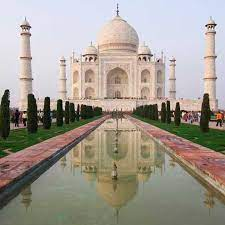How does the architecture of the Taj Mahal incorporate elements of Islamic art? The architecture of the Taj Mahal is a brilliant amalgamation of Islamic art principles, including the use of Islamic arches, intricate arabesque designs, and geometric patterns. The main dome, topped with a lotus design, is an excellent example of this blend. Additionally, the calligraphy on the large pishtaq arches of the entrance gates refers to Islamic traditions, featuring verses from the Quran, which add to the spiritual ambiance of this mausoleum. 